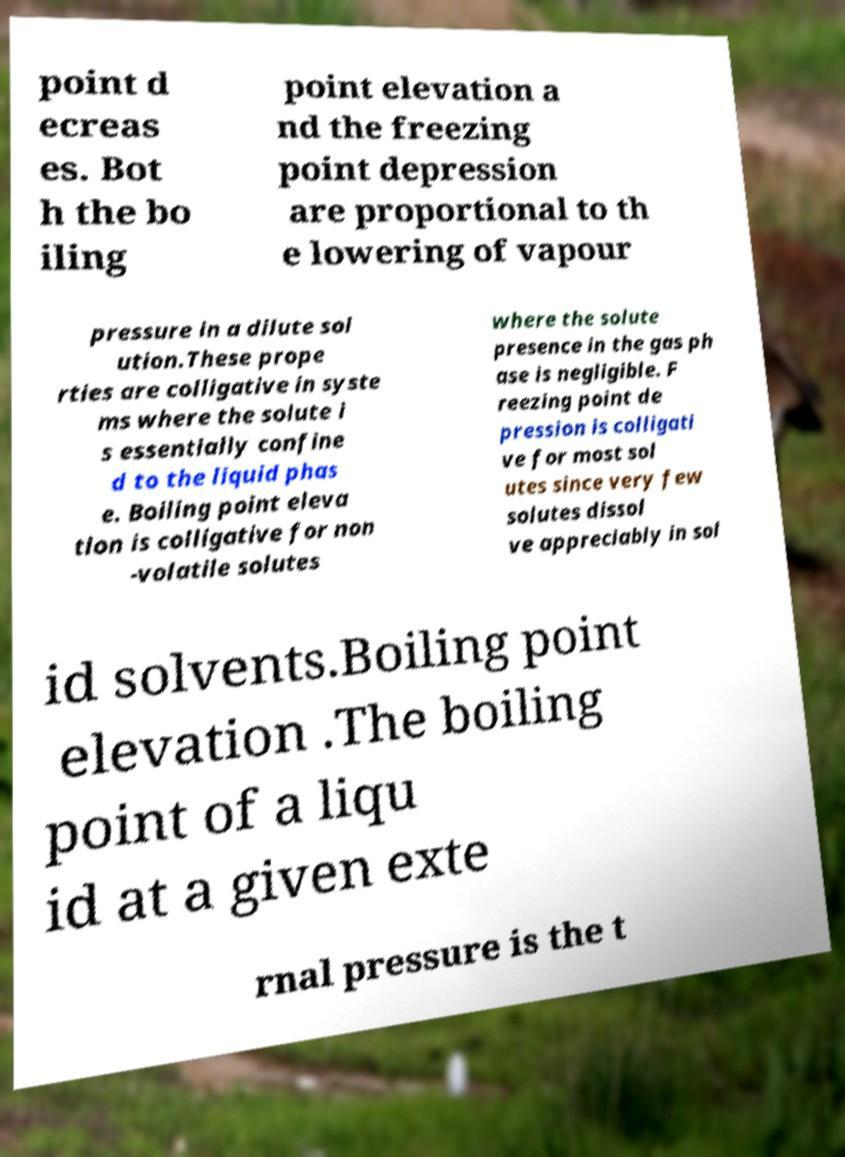Could you extract and type out the text from this image? point d ecreas es. Bot h the bo iling point elevation a nd the freezing point depression are proportional to th e lowering of vapour pressure in a dilute sol ution.These prope rties are colligative in syste ms where the solute i s essentially confine d to the liquid phas e. Boiling point eleva tion is colligative for non -volatile solutes where the solute presence in the gas ph ase is negligible. F reezing point de pression is colligati ve for most sol utes since very few solutes dissol ve appreciably in sol id solvents.Boiling point elevation .The boiling point of a liqu id at a given exte rnal pressure is the t 